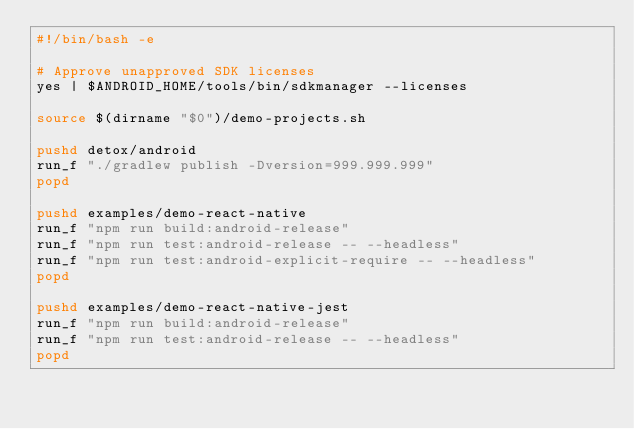<code> <loc_0><loc_0><loc_500><loc_500><_Bash_>#!/bin/bash -e

# Approve unapproved SDK licenses
yes | $ANDROID_HOME/tools/bin/sdkmanager --licenses

source $(dirname "$0")/demo-projects.sh

pushd detox/android
run_f "./gradlew publish -Dversion=999.999.999"
popd

pushd examples/demo-react-native
run_f "npm run build:android-release"
run_f "npm run test:android-release -- --headless"
run_f "npm run test:android-explicit-require -- --headless"
popd

pushd examples/demo-react-native-jest
run_f "npm run build:android-release"
run_f "npm run test:android-release -- --headless"
popd
</code> 